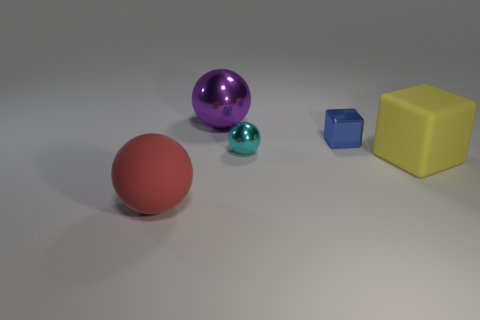What number of tiny things are either yellow metallic cylinders or purple spheres?
Provide a short and direct response. 0. Is the number of big red rubber balls that are right of the big purple metal sphere the same as the number of tiny brown cylinders?
Your response must be concise. Yes. There is a big ball behind the big yellow rubber thing; are there any large red matte objects to the right of it?
Provide a succinct answer. No. How many other objects are the same color as the large matte cube?
Ensure brevity in your answer.  0. What color is the big metallic sphere?
Provide a succinct answer. Purple. There is a thing that is both to the right of the tiny cyan metal sphere and in front of the blue metal object; how big is it?
Offer a very short reply. Large. How many objects are either big things that are on the right side of the red ball or large yellow rubber balls?
Provide a succinct answer. 2. The big red thing that is made of the same material as the yellow thing is what shape?
Your answer should be very brief. Sphere. What is the shape of the cyan object?
Offer a very short reply. Sphere. What is the color of the big thing that is both behind the red rubber object and left of the blue metal object?
Your answer should be very brief. Purple. 